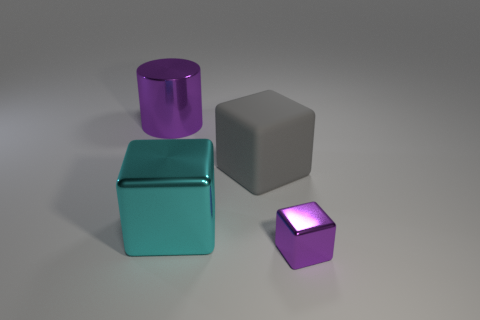What shape is the big metallic object that is the same color as the small metal cube?
Give a very brief answer. Cylinder. There is another purple object that is made of the same material as the small purple object; what shape is it?
Your answer should be compact. Cylinder. Are the gray object and the big object that is in front of the gray matte cube made of the same material?
Your response must be concise. No. There is a large rubber object that is to the right of the purple metallic cylinder; is its shape the same as the big cyan object?
Your answer should be very brief. Yes. What is the material of the purple thing that is the same shape as the gray thing?
Keep it short and to the point. Metal. There is a rubber thing; is it the same shape as the purple metal object to the right of the big cyan metallic thing?
Ensure brevity in your answer.  Yes. The object that is to the right of the cyan metallic block and behind the cyan cube is what color?
Your response must be concise. Gray. Are there any objects?
Offer a very short reply. Yes. Are there the same number of metallic cylinders in front of the tiny cube and big cylinders?
Offer a terse response. No. What number of other objects are the same shape as the tiny purple thing?
Ensure brevity in your answer.  2. 